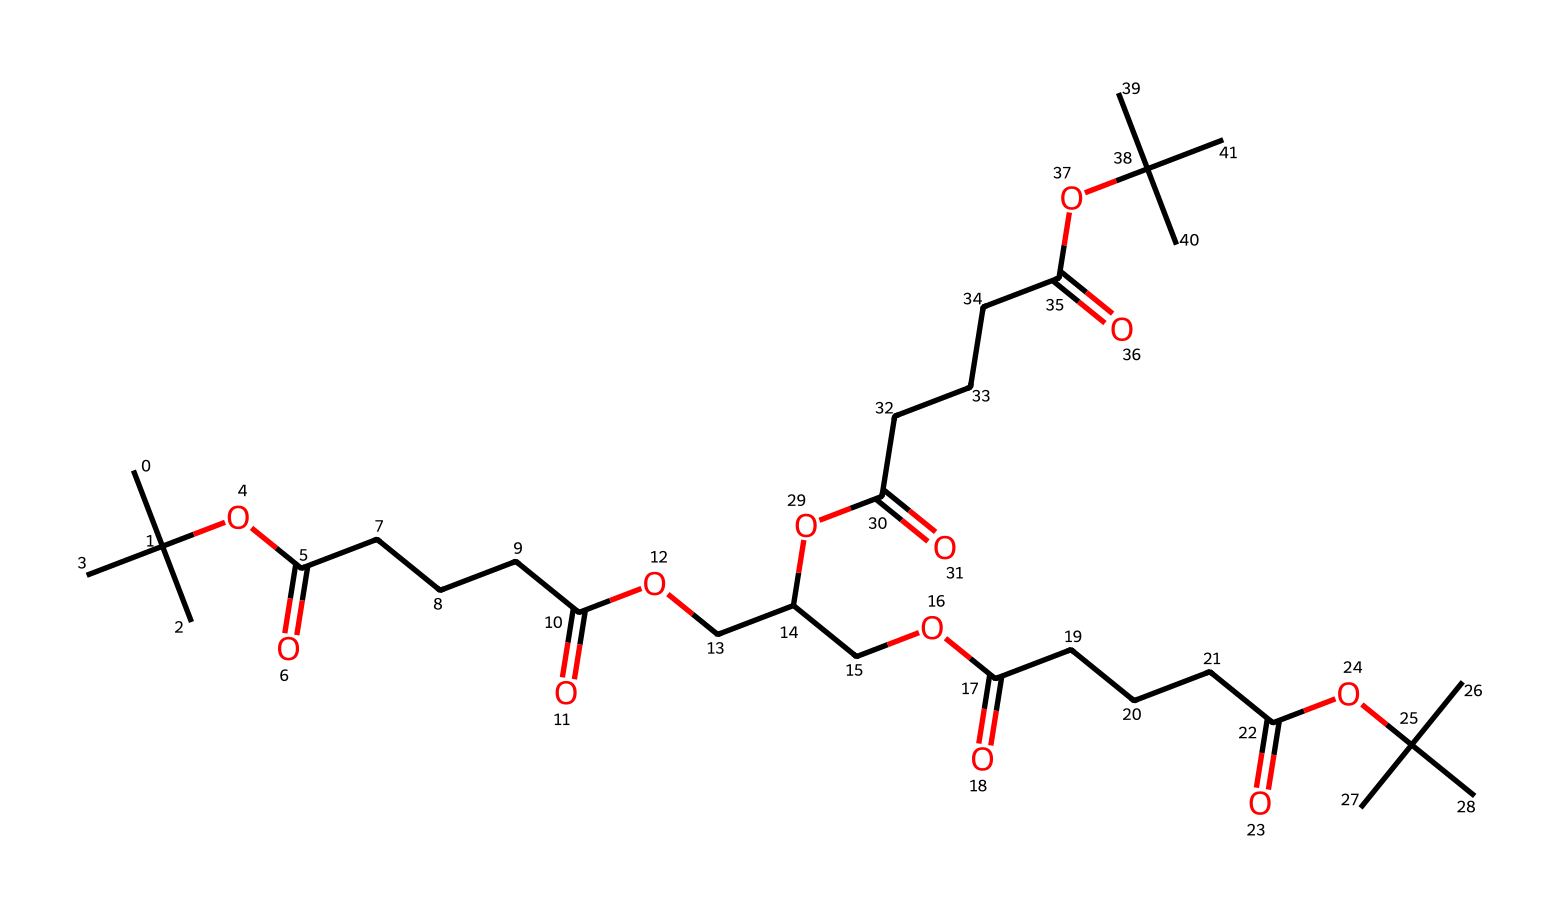What is the general classification of this chemical? This chemical is classified as a polymer due to its long chain structure consisting of repeated monomer units (ester linkages and carbon chains).
Answer: polymer How many carbon atoms are in the structure? By counting the carbon atoms in the structure is observed from the long hydrocarbon chains and branching, which equals 23 carbon atoms.
Answer: 23 What functional groups are present in the chemical? The structure contains ester functional groups (shown by -OC(=O)-) and carboxylic acids (-COOH), indicating it possesses both of these functionalities.
Answer: ester and carboxylic acid What type of bonds predominantly link the monomers in this polymer? The primary bonds linking the monomers are ester bonds, which are formed through the condensation reaction of alcohols and acids (the -OC(=O)- part represents these bonds).
Answer: ester bonds What evidence supports the biodegradability of this polymer? The presence of ester and carboxylic acid groups suggests that this polymer can undergo hydrolysis in the environment, which supports its biodegradability as these groups are typically cleaved by microbial action or in aqueous environments.
Answer: hydrolysis What is the implication of the branching observed in this chemical structure? The branching can improve the mechanical properties of the polymer, such as flexibility and tensile strength, which is critical for applications in energy storage devices where performance is important.
Answer: flexibility and tensile strength 